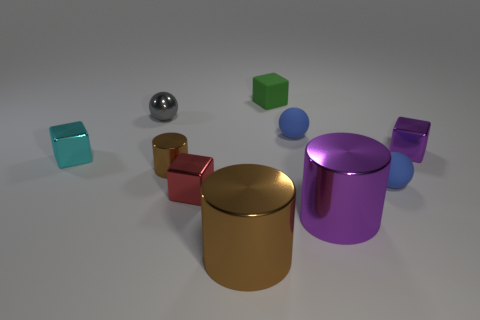Subtract all metallic cubes. How many cubes are left? 1 Subtract all purple cylinders. How many cylinders are left? 2 Subtract all cubes. How many objects are left? 6 Subtract 1 gray spheres. How many objects are left? 9 Subtract 2 cylinders. How many cylinders are left? 1 Subtract all gray cylinders. Subtract all gray blocks. How many cylinders are left? 3 Subtract all purple cubes. How many yellow cylinders are left? 0 Subtract all matte cylinders. Subtract all red shiny blocks. How many objects are left? 9 Add 2 small spheres. How many small spheres are left? 5 Add 10 blue metal blocks. How many blue metal blocks exist? 10 